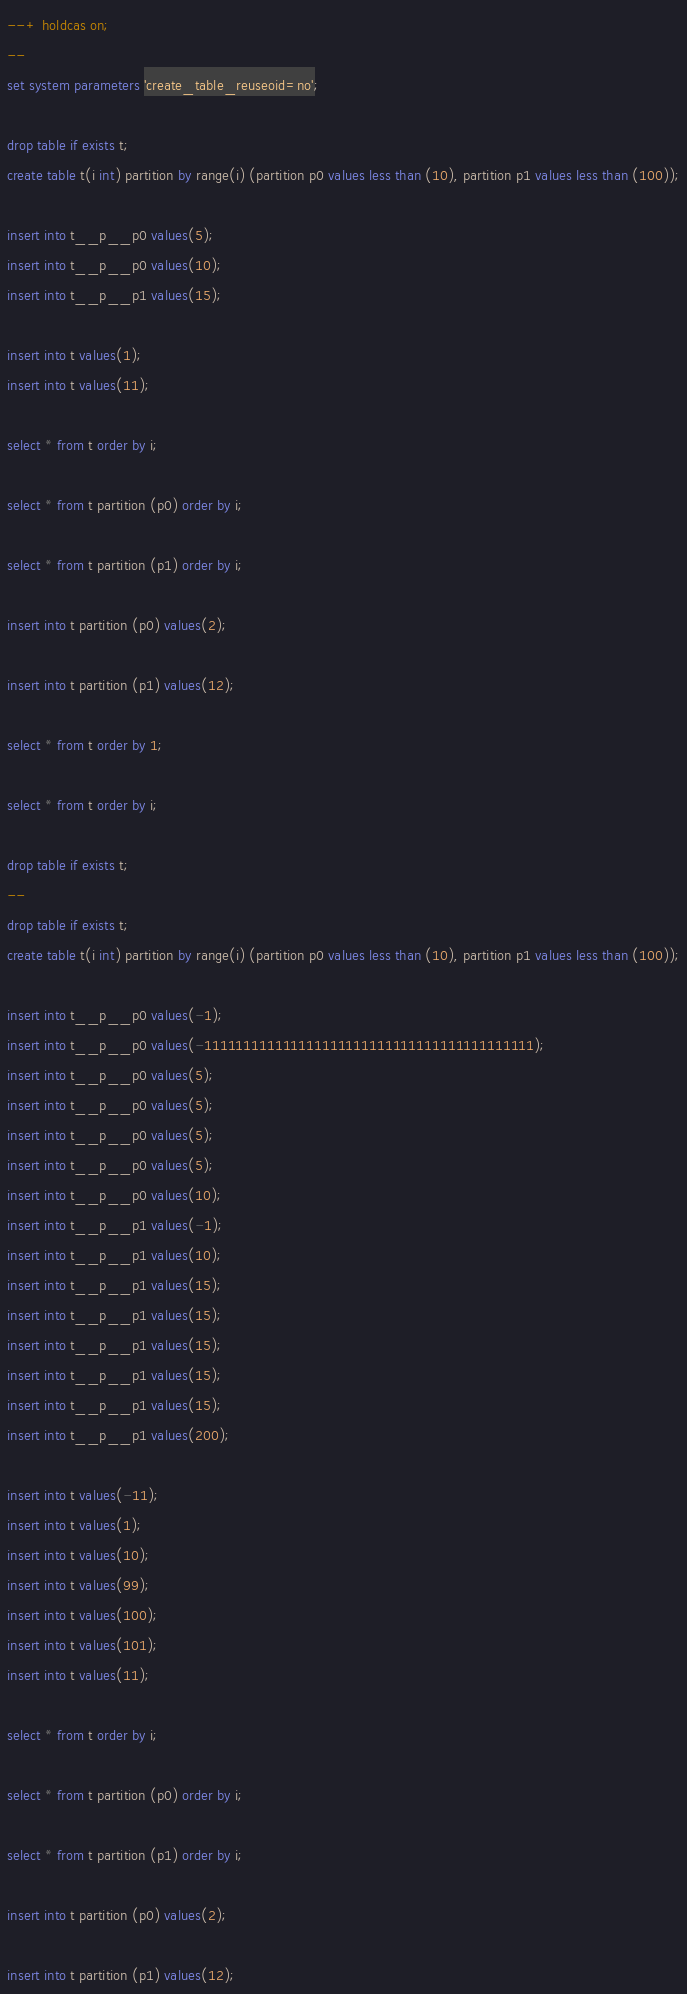Convert code to text. <code><loc_0><loc_0><loc_500><loc_500><_SQL_>--+ holdcas on;
--
set system parameters 'create_table_reuseoid=no';

drop table if exists t;
create table t(i int) partition by range(i) (partition p0 values less than (10), partition p1 values less than (100));

insert into t__p__p0 values(5);
insert into t__p__p0 values(10);
insert into t__p__p1 values(15);

insert into t values(1);
insert into t values(11);

select * from t order by i;

select * from t partition (p0) order by i;

select * from t partition (p1) order by i;

insert into t partition (p0) values(2);

insert into t partition (p1) values(12);

select * from t order by 1;

select * from t order by i;

drop table if exists t;
--
drop table if exists t;
create table t(i int) partition by range(i) (partition p0 values less than (10), partition p1 values less than (100));

insert into t__p__p0 values(-1);
insert into t__p__p0 values(-111111111111111111111111111111111111111111);
insert into t__p__p0 values(5);
insert into t__p__p0 values(5);
insert into t__p__p0 values(5);
insert into t__p__p0 values(5);
insert into t__p__p0 values(10);
insert into t__p__p1 values(-1);
insert into t__p__p1 values(10);
insert into t__p__p1 values(15);
insert into t__p__p1 values(15);
insert into t__p__p1 values(15);
insert into t__p__p1 values(15);
insert into t__p__p1 values(15);
insert into t__p__p1 values(200);

insert into t values(-11);
insert into t values(1);
insert into t values(10);
insert into t values(99);
insert into t values(100);
insert into t values(101);
insert into t values(11);

select * from t order by i;

select * from t partition (p0) order by i;

select * from t partition (p1) order by i;

insert into t partition (p0) values(2);

insert into t partition (p1) values(12);
</code> 